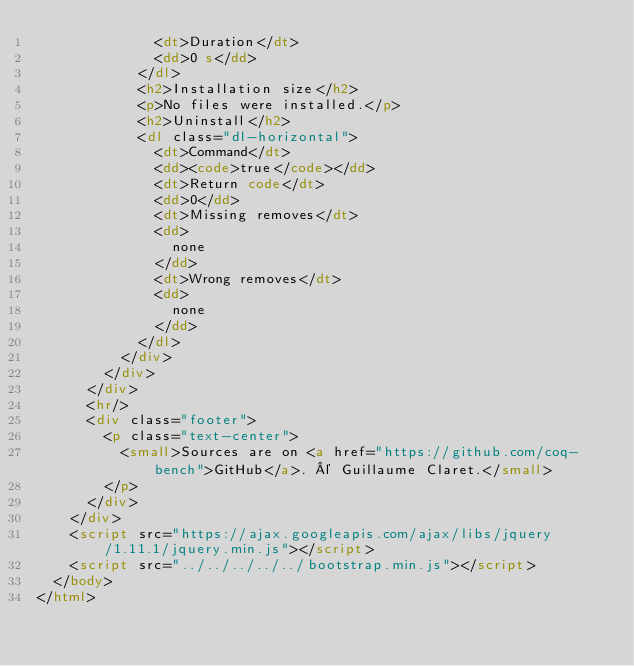<code> <loc_0><loc_0><loc_500><loc_500><_HTML_>              <dt>Duration</dt>
              <dd>0 s</dd>
            </dl>
            <h2>Installation size</h2>
            <p>No files were installed.</p>
            <h2>Uninstall</h2>
            <dl class="dl-horizontal">
              <dt>Command</dt>
              <dd><code>true</code></dd>
              <dt>Return code</dt>
              <dd>0</dd>
              <dt>Missing removes</dt>
              <dd>
                none
              </dd>
              <dt>Wrong removes</dt>
              <dd>
                none
              </dd>
            </dl>
          </div>
        </div>
      </div>
      <hr/>
      <div class="footer">
        <p class="text-center">
          <small>Sources are on <a href="https://github.com/coq-bench">GitHub</a>. © Guillaume Claret.</small>
        </p>
      </div>
    </div>
    <script src="https://ajax.googleapis.com/ajax/libs/jquery/1.11.1/jquery.min.js"></script>
    <script src="../../../../../bootstrap.min.js"></script>
  </body>
</html>
</code> 